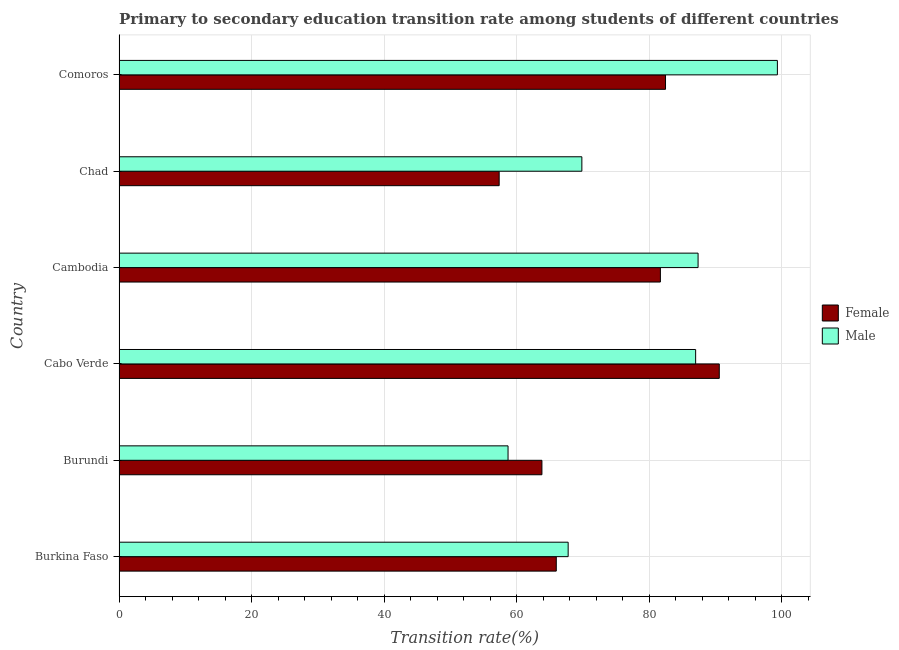How many different coloured bars are there?
Provide a succinct answer. 2. How many groups of bars are there?
Offer a very short reply. 6. Are the number of bars per tick equal to the number of legend labels?
Offer a terse response. Yes. How many bars are there on the 6th tick from the bottom?
Make the answer very short. 2. What is the label of the 4th group of bars from the top?
Offer a very short reply. Cabo Verde. What is the transition rate among male students in Burkina Faso?
Your response must be concise. 67.78. Across all countries, what is the maximum transition rate among female students?
Your response must be concise. 90.59. Across all countries, what is the minimum transition rate among female students?
Provide a short and direct response. 57.37. In which country was the transition rate among female students maximum?
Your response must be concise. Cabo Verde. In which country was the transition rate among male students minimum?
Keep it short and to the point. Burundi. What is the total transition rate among female students in the graph?
Give a very brief answer. 441.96. What is the difference between the transition rate among male students in Cabo Verde and that in Comoros?
Ensure brevity in your answer.  -12.34. What is the difference between the transition rate among female students in Burkina Faso and the transition rate among male students in Cabo Verde?
Provide a succinct answer. -21.03. What is the average transition rate among male students per country?
Keep it short and to the point. 78.35. What is the difference between the transition rate among male students and transition rate among female students in Chad?
Make the answer very short. 12.48. What is the ratio of the transition rate among male students in Burundi to that in Comoros?
Ensure brevity in your answer.  0.59. Is the transition rate among female students in Burundi less than that in Chad?
Keep it short and to the point. No. Is the difference between the transition rate among male students in Burundi and Cambodia greater than the difference between the transition rate among female students in Burundi and Cambodia?
Provide a short and direct response. No. What is the difference between the highest and the second highest transition rate among male students?
Keep it short and to the point. 11.97. What is the difference between the highest and the lowest transition rate among female students?
Provide a short and direct response. 33.22. What does the 1st bar from the top in Cambodia represents?
Your answer should be compact. Male. How many countries are there in the graph?
Ensure brevity in your answer.  6. Are the values on the major ticks of X-axis written in scientific E-notation?
Your response must be concise. No. Where does the legend appear in the graph?
Your response must be concise. Center right. How many legend labels are there?
Provide a short and direct response. 2. What is the title of the graph?
Offer a very short reply. Primary to secondary education transition rate among students of different countries. What is the label or title of the X-axis?
Provide a succinct answer. Transition rate(%). What is the label or title of the Y-axis?
Provide a short and direct response. Country. What is the Transition rate(%) in Female in Burkina Faso?
Offer a very short reply. 65.99. What is the Transition rate(%) in Male in Burkina Faso?
Keep it short and to the point. 67.78. What is the Transition rate(%) in Female in Burundi?
Offer a very short reply. 63.82. What is the Transition rate(%) in Male in Burundi?
Make the answer very short. 58.71. What is the Transition rate(%) of Female in Cabo Verde?
Provide a succinct answer. 90.59. What is the Transition rate(%) of Male in Cabo Verde?
Keep it short and to the point. 87.02. What is the Transition rate(%) of Female in Cambodia?
Your answer should be very brief. 81.7. What is the Transition rate(%) in Male in Cambodia?
Provide a succinct answer. 87.39. What is the Transition rate(%) in Female in Chad?
Provide a succinct answer. 57.37. What is the Transition rate(%) of Male in Chad?
Provide a succinct answer. 69.85. What is the Transition rate(%) in Female in Comoros?
Give a very brief answer. 82.48. What is the Transition rate(%) in Male in Comoros?
Keep it short and to the point. 99.36. Across all countries, what is the maximum Transition rate(%) of Female?
Offer a terse response. 90.59. Across all countries, what is the maximum Transition rate(%) of Male?
Keep it short and to the point. 99.36. Across all countries, what is the minimum Transition rate(%) of Female?
Your response must be concise. 57.37. Across all countries, what is the minimum Transition rate(%) of Male?
Your answer should be very brief. 58.71. What is the total Transition rate(%) in Female in the graph?
Give a very brief answer. 441.96. What is the total Transition rate(%) of Male in the graph?
Give a very brief answer. 470.12. What is the difference between the Transition rate(%) of Female in Burkina Faso and that in Burundi?
Provide a short and direct response. 2.17. What is the difference between the Transition rate(%) of Male in Burkina Faso and that in Burundi?
Provide a short and direct response. 9.07. What is the difference between the Transition rate(%) in Female in Burkina Faso and that in Cabo Verde?
Offer a very short reply. -24.6. What is the difference between the Transition rate(%) in Male in Burkina Faso and that in Cabo Verde?
Offer a terse response. -19.24. What is the difference between the Transition rate(%) of Female in Burkina Faso and that in Cambodia?
Offer a very short reply. -15.71. What is the difference between the Transition rate(%) in Male in Burkina Faso and that in Cambodia?
Keep it short and to the point. -19.61. What is the difference between the Transition rate(%) of Female in Burkina Faso and that in Chad?
Provide a succinct answer. 8.62. What is the difference between the Transition rate(%) of Male in Burkina Faso and that in Chad?
Keep it short and to the point. -2.07. What is the difference between the Transition rate(%) in Female in Burkina Faso and that in Comoros?
Your answer should be very brief. -16.49. What is the difference between the Transition rate(%) in Male in Burkina Faso and that in Comoros?
Provide a succinct answer. -31.58. What is the difference between the Transition rate(%) of Female in Burundi and that in Cabo Verde?
Offer a terse response. -26.77. What is the difference between the Transition rate(%) in Male in Burundi and that in Cabo Verde?
Your response must be concise. -28.31. What is the difference between the Transition rate(%) in Female in Burundi and that in Cambodia?
Ensure brevity in your answer.  -17.88. What is the difference between the Transition rate(%) in Male in Burundi and that in Cambodia?
Your answer should be very brief. -28.68. What is the difference between the Transition rate(%) of Female in Burundi and that in Chad?
Your response must be concise. 6.45. What is the difference between the Transition rate(%) of Male in Burundi and that in Chad?
Make the answer very short. -11.14. What is the difference between the Transition rate(%) of Female in Burundi and that in Comoros?
Ensure brevity in your answer.  -18.66. What is the difference between the Transition rate(%) in Male in Burundi and that in Comoros?
Give a very brief answer. -40.65. What is the difference between the Transition rate(%) in Female in Cabo Verde and that in Cambodia?
Your response must be concise. 8.89. What is the difference between the Transition rate(%) of Male in Cabo Verde and that in Cambodia?
Give a very brief answer. -0.37. What is the difference between the Transition rate(%) of Female in Cabo Verde and that in Chad?
Your response must be concise. 33.22. What is the difference between the Transition rate(%) of Male in Cabo Verde and that in Chad?
Keep it short and to the point. 17.17. What is the difference between the Transition rate(%) in Female in Cabo Verde and that in Comoros?
Your answer should be compact. 8.11. What is the difference between the Transition rate(%) of Male in Cabo Verde and that in Comoros?
Your answer should be very brief. -12.34. What is the difference between the Transition rate(%) in Female in Cambodia and that in Chad?
Your answer should be very brief. 24.33. What is the difference between the Transition rate(%) of Male in Cambodia and that in Chad?
Make the answer very short. 17.54. What is the difference between the Transition rate(%) of Female in Cambodia and that in Comoros?
Your response must be concise. -0.77. What is the difference between the Transition rate(%) of Male in Cambodia and that in Comoros?
Your response must be concise. -11.97. What is the difference between the Transition rate(%) of Female in Chad and that in Comoros?
Keep it short and to the point. -25.11. What is the difference between the Transition rate(%) of Male in Chad and that in Comoros?
Your answer should be very brief. -29.51. What is the difference between the Transition rate(%) of Female in Burkina Faso and the Transition rate(%) of Male in Burundi?
Your response must be concise. 7.28. What is the difference between the Transition rate(%) in Female in Burkina Faso and the Transition rate(%) in Male in Cabo Verde?
Offer a very short reply. -21.03. What is the difference between the Transition rate(%) of Female in Burkina Faso and the Transition rate(%) of Male in Cambodia?
Your answer should be compact. -21.4. What is the difference between the Transition rate(%) in Female in Burkina Faso and the Transition rate(%) in Male in Chad?
Give a very brief answer. -3.86. What is the difference between the Transition rate(%) of Female in Burkina Faso and the Transition rate(%) of Male in Comoros?
Provide a succinct answer. -33.37. What is the difference between the Transition rate(%) of Female in Burundi and the Transition rate(%) of Male in Cabo Verde?
Give a very brief answer. -23.2. What is the difference between the Transition rate(%) in Female in Burundi and the Transition rate(%) in Male in Cambodia?
Offer a very short reply. -23.57. What is the difference between the Transition rate(%) in Female in Burundi and the Transition rate(%) in Male in Chad?
Provide a succinct answer. -6.03. What is the difference between the Transition rate(%) of Female in Burundi and the Transition rate(%) of Male in Comoros?
Keep it short and to the point. -35.54. What is the difference between the Transition rate(%) of Female in Cabo Verde and the Transition rate(%) of Male in Cambodia?
Offer a very short reply. 3.2. What is the difference between the Transition rate(%) in Female in Cabo Verde and the Transition rate(%) in Male in Chad?
Ensure brevity in your answer.  20.74. What is the difference between the Transition rate(%) in Female in Cabo Verde and the Transition rate(%) in Male in Comoros?
Provide a short and direct response. -8.77. What is the difference between the Transition rate(%) in Female in Cambodia and the Transition rate(%) in Male in Chad?
Make the answer very short. 11.85. What is the difference between the Transition rate(%) of Female in Cambodia and the Transition rate(%) of Male in Comoros?
Keep it short and to the point. -17.66. What is the difference between the Transition rate(%) of Female in Chad and the Transition rate(%) of Male in Comoros?
Provide a succinct answer. -41.99. What is the average Transition rate(%) in Female per country?
Your answer should be very brief. 73.66. What is the average Transition rate(%) in Male per country?
Give a very brief answer. 78.35. What is the difference between the Transition rate(%) in Female and Transition rate(%) in Male in Burkina Faso?
Keep it short and to the point. -1.79. What is the difference between the Transition rate(%) of Female and Transition rate(%) of Male in Burundi?
Offer a terse response. 5.11. What is the difference between the Transition rate(%) of Female and Transition rate(%) of Male in Cabo Verde?
Make the answer very short. 3.57. What is the difference between the Transition rate(%) in Female and Transition rate(%) in Male in Cambodia?
Offer a terse response. -5.69. What is the difference between the Transition rate(%) in Female and Transition rate(%) in Male in Chad?
Your answer should be compact. -12.48. What is the difference between the Transition rate(%) in Female and Transition rate(%) in Male in Comoros?
Your answer should be very brief. -16.88. What is the ratio of the Transition rate(%) in Female in Burkina Faso to that in Burundi?
Provide a succinct answer. 1.03. What is the ratio of the Transition rate(%) in Male in Burkina Faso to that in Burundi?
Your answer should be very brief. 1.15. What is the ratio of the Transition rate(%) of Female in Burkina Faso to that in Cabo Verde?
Make the answer very short. 0.73. What is the ratio of the Transition rate(%) in Male in Burkina Faso to that in Cabo Verde?
Give a very brief answer. 0.78. What is the ratio of the Transition rate(%) of Female in Burkina Faso to that in Cambodia?
Make the answer very short. 0.81. What is the ratio of the Transition rate(%) of Male in Burkina Faso to that in Cambodia?
Provide a short and direct response. 0.78. What is the ratio of the Transition rate(%) of Female in Burkina Faso to that in Chad?
Make the answer very short. 1.15. What is the ratio of the Transition rate(%) of Male in Burkina Faso to that in Chad?
Provide a short and direct response. 0.97. What is the ratio of the Transition rate(%) in Female in Burkina Faso to that in Comoros?
Your response must be concise. 0.8. What is the ratio of the Transition rate(%) in Male in Burkina Faso to that in Comoros?
Offer a terse response. 0.68. What is the ratio of the Transition rate(%) in Female in Burundi to that in Cabo Verde?
Your answer should be very brief. 0.7. What is the ratio of the Transition rate(%) in Male in Burundi to that in Cabo Verde?
Provide a short and direct response. 0.67. What is the ratio of the Transition rate(%) in Female in Burundi to that in Cambodia?
Ensure brevity in your answer.  0.78. What is the ratio of the Transition rate(%) in Male in Burundi to that in Cambodia?
Your answer should be compact. 0.67. What is the ratio of the Transition rate(%) of Female in Burundi to that in Chad?
Offer a very short reply. 1.11. What is the ratio of the Transition rate(%) of Male in Burundi to that in Chad?
Your answer should be compact. 0.84. What is the ratio of the Transition rate(%) in Female in Burundi to that in Comoros?
Keep it short and to the point. 0.77. What is the ratio of the Transition rate(%) in Male in Burundi to that in Comoros?
Give a very brief answer. 0.59. What is the ratio of the Transition rate(%) of Female in Cabo Verde to that in Cambodia?
Make the answer very short. 1.11. What is the ratio of the Transition rate(%) of Female in Cabo Verde to that in Chad?
Offer a very short reply. 1.58. What is the ratio of the Transition rate(%) of Male in Cabo Verde to that in Chad?
Ensure brevity in your answer.  1.25. What is the ratio of the Transition rate(%) in Female in Cabo Verde to that in Comoros?
Your response must be concise. 1.1. What is the ratio of the Transition rate(%) of Male in Cabo Verde to that in Comoros?
Your response must be concise. 0.88. What is the ratio of the Transition rate(%) in Female in Cambodia to that in Chad?
Give a very brief answer. 1.42. What is the ratio of the Transition rate(%) in Male in Cambodia to that in Chad?
Your answer should be compact. 1.25. What is the ratio of the Transition rate(%) in Female in Cambodia to that in Comoros?
Your answer should be compact. 0.99. What is the ratio of the Transition rate(%) of Male in Cambodia to that in Comoros?
Your answer should be compact. 0.88. What is the ratio of the Transition rate(%) in Female in Chad to that in Comoros?
Your answer should be compact. 0.7. What is the ratio of the Transition rate(%) in Male in Chad to that in Comoros?
Your answer should be very brief. 0.7. What is the difference between the highest and the second highest Transition rate(%) of Female?
Keep it short and to the point. 8.11. What is the difference between the highest and the second highest Transition rate(%) of Male?
Offer a terse response. 11.97. What is the difference between the highest and the lowest Transition rate(%) of Female?
Offer a very short reply. 33.22. What is the difference between the highest and the lowest Transition rate(%) in Male?
Make the answer very short. 40.65. 